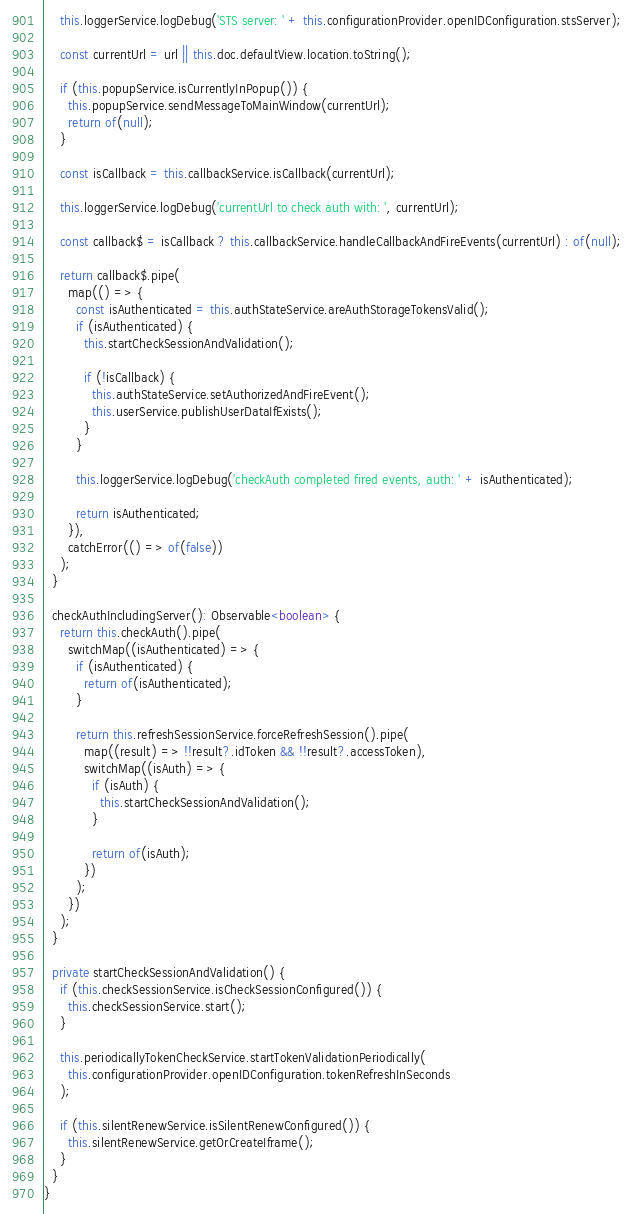<code> <loc_0><loc_0><loc_500><loc_500><_TypeScript_>    this.loggerService.logDebug('STS server: ' + this.configurationProvider.openIDConfiguration.stsServer);

    const currentUrl = url || this.doc.defaultView.location.toString();

    if (this.popupService.isCurrentlyInPopup()) {
      this.popupService.sendMessageToMainWindow(currentUrl);
      return of(null);
    }

    const isCallback = this.callbackService.isCallback(currentUrl);

    this.loggerService.logDebug('currentUrl to check auth with: ', currentUrl);

    const callback$ = isCallback ? this.callbackService.handleCallbackAndFireEvents(currentUrl) : of(null);

    return callback$.pipe(
      map(() => {
        const isAuthenticated = this.authStateService.areAuthStorageTokensValid();
        if (isAuthenticated) {
          this.startCheckSessionAndValidation();

          if (!isCallback) {
            this.authStateService.setAuthorizedAndFireEvent();
            this.userService.publishUserDataIfExists();
          }
        }

        this.loggerService.logDebug('checkAuth completed fired events, auth: ' + isAuthenticated);

        return isAuthenticated;
      }),
      catchError(() => of(false))
    );
  }

  checkAuthIncludingServer(): Observable<boolean> {
    return this.checkAuth().pipe(
      switchMap((isAuthenticated) => {
        if (isAuthenticated) {
          return of(isAuthenticated);
        }

        return this.refreshSessionService.forceRefreshSession().pipe(
          map((result) => !!result?.idToken && !!result?.accessToken),
          switchMap((isAuth) => {
            if (isAuth) {
              this.startCheckSessionAndValidation();
            }

            return of(isAuth);
          })
        );
      })
    );
  }

  private startCheckSessionAndValidation() {
    if (this.checkSessionService.isCheckSessionConfigured()) {
      this.checkSessionService.start();
    }

    this.periodicallyTokenCheckService.startTokenValidationPeriodically(
      this.configurationProvider.openIDConfiguration.tokenRefreshInSeconds
    );

    if (this.silentRenewService.isSilentRenewConfigured()) {
      this.silentRenewService.getOrCreateIframe();
    }
  }
}
</code> 